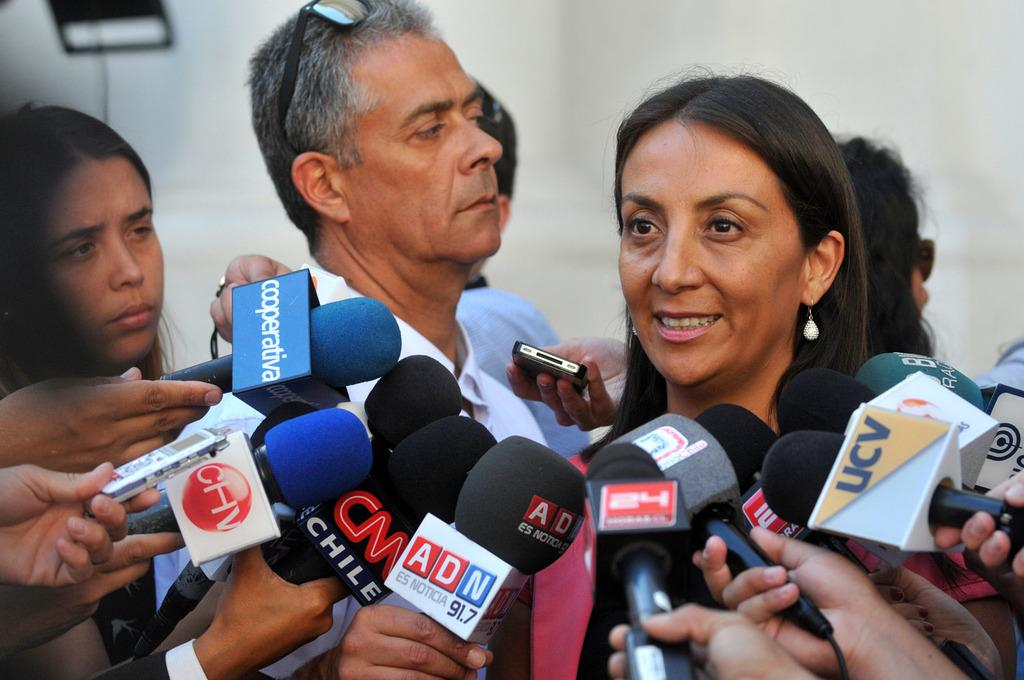What is the main subject of the image? The main subject of the image is a group of people. What can be seen in front of the group of people? There are microphones in front of the group of people. What are some people holding in the image? Some people are holding mobile devices. What can be seen in the background of the image? There are objects visible in the background of the image. What type of fork can be seen in the hands of one of the people in the image? There is no fork present in the image; the people are holding mobile devices. 